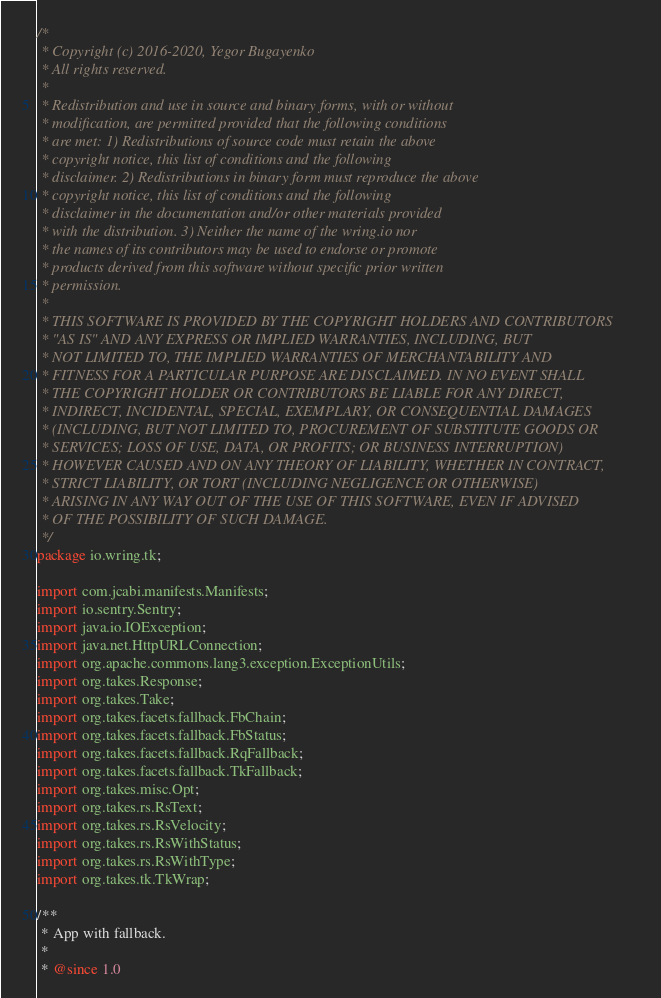Convert code to text. <code><loc_0><loc_0><loc_500><loc_500><_Java_>/*
 * Copyright (c) 2016-2020, Yegor Bugayenko
 * All rights reserved.
 *
 * Redistribution and use in source and binary forms, with or without
 * modification, are permitted provided that the following conditions
 * are met: 1) Redistributions of source code must retain the above
 * copyright notice, this list of conditions and the following
 * disclaimer. 2) Redistributions in binary form must reproduce the above
 * copyright notice, this list of conditions and the following
 * disclaimer in the documentation and/or other materials provided
 * with the distribution. 3) Neither the name of the wring.io nor
 * the names of its contributors may be used to endorse or promote
 * products derived from this software without specific prior written
 * permission.
 *
 * THIS SOFTWARE IS PROVIDED BY THE COPYRIGHT HOLDERS AND CONTRIBUTORS
 * "AS IS" AND ANY EXPRESS OR IMPLIED WARRANTIES, INCLUDING, BUT
 * NOT LIMITED TO, THE IMPLIED WARRANTIES OF MERCHANTABILITY AND
 * FITNESS FOR A PARTICULAR PURPOSE ARE DISCLAIMED. IN NO EVENT SHALL
 * THE COPYRIGHT HOLDER OR CONTRIBUTORS BE LIABLE FOR ANY DIRECT,
 * INDIRECT, INCIDENTAL, SPECIAL, EXEMPLARY, OR CONSEQUENTIAL DAMAGES
 * (INCLUDING, BUT NOT LIMITED TO, PROCUREMENT OF SUBSTITUTE GOODS OR
 * SERVICES; LOSS OF USE, DATA, OR PROFITS; OR BUSINESS INTERRUPTION)
 * HOWEVER CAUSED AND ON ANY THEORY OF LIABILITY, WHETHER IN CONTRACT,
 * STRICT LIABILITY, OR TORT (INCLUDING NEGLIGENCE OR OTHERWISE)
 * ARISING IN ANY WAY OUT OF THE USE OF THIS SOFTWARE, EVEN IF ADVISED
 * OF THE POSSIBILITY OF SUCH DAMAGE.
 */
package io.wring.tk;

import com.jcabi.manifests.Manifests;
import io.sentry.Sentry;
import java.io.IOException;
import java.net.HttpURLConnection;
import org.apache.commons.lang3.exception.ExceptionUtils;
import org.takes.Response;
import org.takes.Take;
import org.takes.facets.fallback.FbChain;
import org.takes.facets.fallback.FbStatus;
import org.takes.facets.fallback.RqFallback;
import org.takes.facets.fallback.TkFallback;
import org.takes.misc.Opt;
import org.takes.rs.RsText;
import org.takes.rs.RsVelocity;
import org.takes.rs.RsWithStatus;
import org.takes.rs.RsWithType;
import org.takes.tk.TkWrap;

/**
 * App with fallback.
 *
 * @since 1.0</code> 